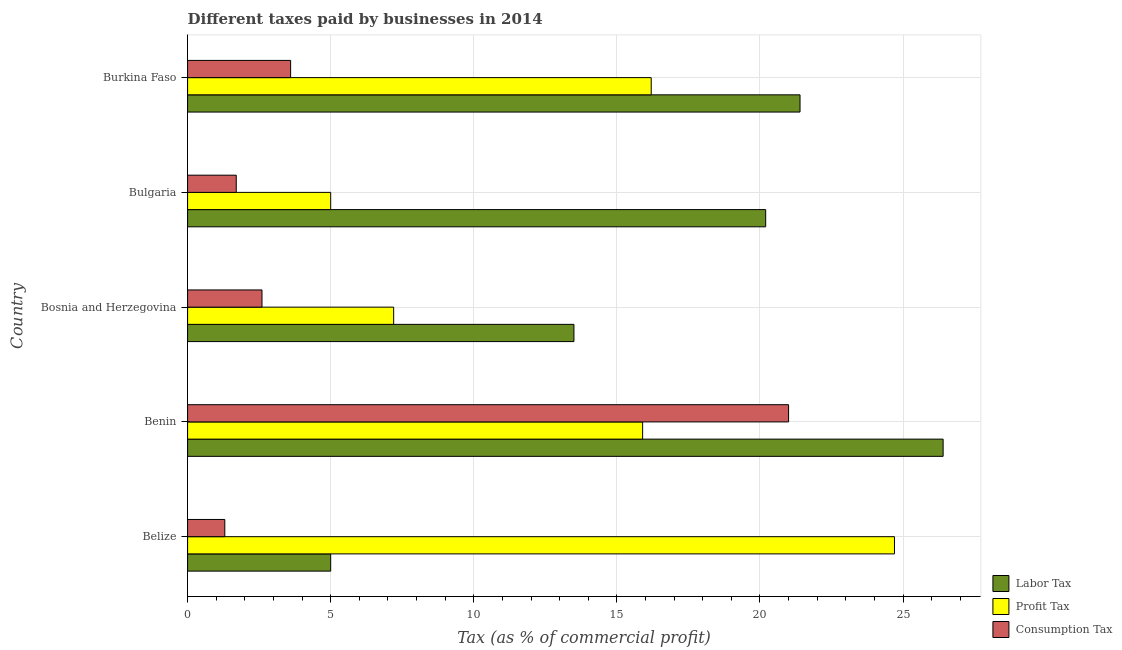How many different coloured bars are there?
Your answer should be compact. 3. How many groups of bars are there?
Provide a short and direct response. 5. How many bars are there on the 1st tick from the top?
Make the answer very short. 3. What is the label of the 2nd group of bars from the top?
Offer a terse response. Bulgaria. Across all countries, what is the maximum percentage of profit tax?
Make the answer very short. 24.7. In which country was the percentage of labor tax maximum?
Offer a very short reply. Benin. What is the total percentage of consumption tax in the graph?
Ensure brevity in your answer.  30.2. What is the difference between the percentage of consumption tax in Benin and that in Bosnia and Herzegovina?
Keep it short and to the point. 18.4. What is the difference between the percentage of consumption tax in Benin and the percentage of profit tax in Bosnia and Herzegovina?
Give a very brief answer. 13.8. In how many countries, is the percentage of profit tax greater than 13 %?
Keep it short and to the point. 3. What is the ratio of the percentage of profit tax in Belize to that in Burkina Faso?
Make the answer very short. 1.52. What is the difference between the highest and the second highest percentage of labor tax?
Provide a succinct answer. 5. What does the 3rd bar from the top in Benin represents?
Offer a very short reply. Labor Tax. What does the 1st bar from the bottom in Burkina Faso represents?
Make the answer very short. Labor Tax. Is it the case that in every country, the sum of the percentage of labor tax and percentage of profit tax is greater than the percentage of consumption tax?
Give a very brief answer. Yes. Are the values on the major ticks of X-axis written in scientific E-notation?
Make the answer very short. No. Does the graph contain any zero values?
Provide a short and direct response. No. Where does the legend appear in the graph?
Your response must be concise. Bottom right. How are the legend labels stacked?
Your answer should be very brief. Vertical. What is the title of the graph?
Make the answer very short. Different taxes paid by businesses in 2014. What is the label or title of the X-axis?
Give a very brief answer. Tax (as % of commercial profit). What is the Tax (as % of commercial profit) of Profit Tax in Belize?
Your response must be concise. 24.7. What is the Tax (as % of commercial profit) of Consumption Tax in Belize?
Offer a terse response. 1.3. What is the Tax (as % of commercial profit) in Labor Tax in Benin?
Keep it short and to the point. 26.4. What is the Tax (as % of commercial profit) in Profit Tax in Benin?
Your response must be concise. 15.9. What is the Tax (as % of commercial profit) of Labor Tax in Bosnia and Herzegovina?
Your answer should be compact. 13.5. What is the Tax (as % of commercial profit) in Profit Tax in Bosnia and Herzegovina?
Offer a very short reply. 7.2. What is the Tax (as % of commercial profit) in Labor Tax in Bulgaria?
Your answer should be compact. 20.2. What is the Tax (as % of commercial profit) in Profit Tax in Bulgaria?
Keep it short and to the point. 5. What is the Tax (as % of commercial profit) of Consumption Tax in Bulgaria?
Provide a succinct answer. 1.7. What is the Tax (as % of commercial profit) of Labor Tax in Burkina Faso?
Your answer should be compact. 21.4. What is the Tax (as % of commercial profit) of Profit Tax in Burkina Faso?
Provide a succinct answer. 16.2. What is the Tax (as % of commercial profit) of Consumption Tax in Burkina Faso?
Provide a short and direct response. 3.6. Across all countries, what is the maximum Tax (as % of commercial profit) in Labor Tax?
Offer a terse response. 26.4. Across all countries, what is the maximum Tax (as % of commercial profit) of Profit Tax?
Give a very brief answer. 24.7. Across all countries, what is the maximum Tax (as % of commercial profit) of Consumption Tax?
Offer a very short reply. 21. Across all countries, what is the minimum Tax (as % of commercial profit) in Profit Tax?
Provide a succinct answer. 5. Across all countries, what is the minimum Tax (as % of commercial profit) in Consumption Tax?
Your answer should be very brief. 1.3. What is the total Tax (as % of commercial profit) in Labor Tax in the graph?
Provide a succinct answer. 86.5. What is the total Tax (as % of commercial profit) in Consumption Tax in the graph?
Make the answer very short. 30.2. What is the difference between the Tax (as % of commercial profit) of Labor Tax in Belize and that in Benin?
Keep it short and to the point. -21.4. What is the difference between the Tax (as % of commercial profit) in Consumption Tax in Belize and that in Benin?
Provide a short and direct response. -19.7. What is the difference between the Tax (as % of commercial profit) in Profit Tax in Belize and that in Bosnia and Herzegovina?
Your answer should be compact. 17.5. What is the difference between the Tax (as % of commercial profit) of Labor Tax in Belize and that in Bulgaria?
Keep it short and to the point. -15.2. What is the difference between the Tax (as % of commercial profit) in Labor Tax in Belize and that in Burkina Faso?
Your answer should be compact. -16.4. What is the difference between the Tax (as % of commercial profit) of Profit Tax in Belize and that in Burkina Faso?
Ensure brevity in your answer.  8.5. What is the difference between the Tax (as % of commercial profit) in Labor Tax in Benin and that in Bosnia and Herzegovina?
Provide a short and direct response. 12.9. What is the difference between the Tax (as % of commercial profit) in Profit Tax in Benin and that in Bulgaria?
Ensure brevity in your answer.  10.9. What is the difference between the Tax (as % of commercial profit) in Consumption Tax in Benin and that in Bulgaria?
Your answer should be very brief. 19.3. What is the difference between the Tax (as % of commercial profit) of Labor Tax in Benin and that in Burkina Faso?
Your answer should be compact. 5. What is the difference between the Tax (as % of commercial profit) in Consumption Tax in Benin and that in Burkina Faso?
Give a very brief answer. 17.4. What is the difference between the Tax (as % of commercial profit) in Labor Tax in Bosnia and Herzegovina and that in Bulgaria?
Ensure brevity in your answer.  -6.7. What is the difference between the Tax (as % of commercial profit) in Profit Tax in Bosnia and Herzegovina and that in Bulgaria?
Your answer should be compact. 2.2. What is the difference between the Tax (as % of commercial profit) of Profit Tax in Bulgaria and that in Burkina Faso?
Provide a short and direct response. -11.2. What is the difference between the Tax (as % of commercial profit) of Consumption Tax in Bulgaria and that in Burkina Faso?
Provide a short and direct response. -1.9. What is the difference between the Tax (as % of commercial profit) of Labor Tax in Belize and the Tax (as % of commercial profit) of Profit Tax in Bosnia and Herzegovina?
Give a very brief answer. -2.2. What is the difference between the Tax (as % of commercial profit) in Profit Tax in Belize and the Tax (as % of commercial profit) in Consumption Tax in Bosnia and Herzegovina?
Your answer should be very brief. 22.1. What is the difference between the Tax (as % of commercial profit) in Labor Tax in Belize and the Tax (as % of commercial profit) in Profit Tax in Bulgaria?
Provide a short and direct response. 0. What is the difference between the Tax (as % of commercial profit) of Labor Tax in Belize and the Tax (as % of commercial profit) of Consumption Tax in Bulgaria?
Keep it short and to the point. 3.3. What is the difference between the Tax (as % of commercial profit) in Profit Tax in Belize and the Tax (as % of commercial profit) in Consumption Tax in Burkina Faso?
Offer a very short reply. 21.1. What is the difference between the Tax (as % of commercial profit) in Labor Tax in Benin and the Tax (as % of commercial profit) in Profit Tax in Bosnia and Herzegovina?
Make the answer very short. 19.2. What is the difference between the Tax (as % of commercial profit) of Labor Tax in Benin and the Tax (as % of commercial profit) of Consumption Tax in Bosnia and Herzegovina?
Ensure brevity in your answer.  23.8. What is the difference between the Tax (as % of commercial profit) in Labor Tax in Benin and the Tax (as % of commercial profit) in Profit Tax in Bulgaria?
Provide a short and direct response. 21.4. What is the difference between the Tax (as % of commercial profit) in Labor Tax in Benin and the Tax (as % of commercial profit) in Consumption Tax in Bulgaria?
Give a very brief answer. 24.7. What is the difference between the Tax (as % of commercial profit) in Profit Tax in Benin and the Tax (as % of commercial profit) in Consumption Tax in Bulgaria?
Ensure brevity in your answer.  14.2. What is the difference between the Tax (as % of commercial profit) in Labor Tax in Benin and the Tax (as % of commercial profit) in Consumption Tax in Burkina Faso?
Your answer should be very brief. 22.8. What is the difference between the Tax (as % of commercial profit) in Labor Tax in Bosnia and Herzegovina and the Tax (as % of commercial profit) in Profit Tax in Bulgaria?
Provide a short and direct response. 8.5. What is the difference between the Tax (as % of commercial profit) of Labor Tax in Bosnia and Herzegovina and the Tax (as % of commercial profit) of Consumption Tax in Bulgaria?
Provide a short and direct response. 11.8. What is the difference between the Tax (as % of commercial profit) of Profit Tax in Bosnia and Herzegovina and the Tax (as % of commercial profit) of Consumption Tax in Bulgaria?
Keep it short and to the point. 5.5. What is the difference between the Tax (as % of commercial profit) of Labor Tax in Bosnia and Herzegovina and the Tax (as % of commercial profit) of Consumption Tax in Burkina Faso?
Your answer should be compact. 9.9. What is the difference between the Tax (as % of commercial profit) in Labor Tax in Bulgaria and the Tax (as % of commercial profit) in Profit Tax in Burkina Faso?
Offer a terse response. 4. What is the difference between the Tax (as % of commercial profit) in Labor Tax in Bulgaria and the Tax (as % of commercial profit) in Consumption Tax in Burkina Faso?
Your answer should be very brief. 16.6. What is the difference between the Tax (as % of commercial profit) in Profit Tax in Bulgaria and the Tax (as % of commercial profit) in Consumption Tax in Burkina Faso?
Provide a succinct answer. 1.4. What is the average Tax (as % of commercial profit) in Profit Tax per country?
Make the answer very short. 13.8. What is the average Tax (as % of commercial profit) of Consumption Tax per country?
Your answer should be very brief. 6.04. What is the difference between the Tax (as % of commercial profit) in Labor Tax and Tax (as % of commercial profit) in Profit Tax in Belize?
Make the answer very short. -19.7. What is the difference between the Tax (as % of commercial profit) in Labor Tax and Tax (as % of commercial profit) in Consumption Tax in Belize?
Offer a terse response. 3.7. What is the difference between the Tax (as % of commercial profit) in Profit Tax and Tax (as % of commercial profit) in Consumption Tax in Belize?
Make the answer very short. 23.4. What is the difference between the Tax (as % of commercial profit) of Labor Tax and Tax (as % of commercial profit) of Profit Tax in Benin?
Your response must be concise. 10.5. What is the difference between the Tax (as % of commercial profit) in Profit Tax and Tax (as % of commercial profit) in Consumption Tax in Benin?
Your answer should be compact. -5.1. What is the difference between the Tax (as % of commercial profit) in Labor Tax and Tax (as % of commercial profit) in Profit Tax in Bosnia and Herzegovina?
Your answer should be very brief. 6.3. What is the difference between the Tax (as % of commercial profit) in Labor Tax and Tax (as % of commercial profit) in Consumption Tax in Bulgaria?
Your answer should be very brief. 18.5. What is the difference between the Tax (as % of commercial profit) of Profit Tax and Tax (as % of commercial profit) of Consumption Tax in Bulgaria?
Provide a succinct answer. 3.3. What is the difference between the Tax (as % of commercial profit) of Labor Tax and Tax (as % of commercial profit) of Profit Tax in Burkina Faso?
Provide a succinct answer. 5.2. What is the ratio of the Tax (as % of commercial profit) in Labor Tax in Belize to that in Benin?
Your answer should be compact. 0.19. What is the ratio of the Tax (as % of commercial profit) of Profit Tax in Belize to that in Benin?
Offer a very short reply. 1.55. What is the ratio of the Tax (as % of commercial profit) of Consumption Tax in Belize to that in Benin?
Make the answer very short. 0.06. What is the ratio of the Tax (as % of commercial profit) of Labor Tax in Belize to that in Bosnia and Herzegovina?
Your answer should be very brief. 0.37. What is the ratio of the Tax (as % of commercial profit) in Profit Tax in Belize to that in Bosnia and Herzegovina?
Your response must be concise. 3.43. What is the ratio of the Tax (as % of commercial profit) in Consumption Tax in Belize to that in Bosnia and Herzegovina?
Your response must be concise. 0.5. What is the ratio of the Tax (as % of commercial profit) in Labor Tax in Belize to that in Bulgaria?
Your answer should be very brief. 0.25. What is the ratio of the Tax (as % of commercial profit) in Profit Tax in Belize to that in Bulgaria?
Your answer should be compact. 4.94. What is the ratio of the Tax (as % of commercial profit) of Consumption Tax in Belize to that in Bulgaria?
Offer a very short reply. 0.76. What is the ratio of the Tax (as % of commercial profit) in Labor Tax in Belize to that in Burkina Faso?
Your answer should be very brief. 0.23. What is the ratio of the Tax (as % of commercial profit) in Profit Tax in Belize to that in Burkina Faso?
Make the answer very short. 1.52. What is the ratio of the Tax (as % of commercial profit) in Consumption Tax in Belize to that in Burkina Faso?
Offer a very short reply. 0.36. What is the ratio of the Tax (as % of commercial profit) in Labor Tax in Benin to that in Bosnia and Herzegovina?
Your answer should be compact. 1.96. What is the ratio of the Tax (as % of commercial profit) in Profit Tax in Benin to that in Bosnia and Herzegovina?
Offer a terse response. 2.21. What is the ratio of the Tax (as % of commercial profit) in Consumption Tax in Benin to that in Bosnia and Herzegovina?
Your response must be concise. 8.08. What is the ratio of the Tax (as % of commercial profit) of Labor Tax in Benin to that in Bulgaria?
Provide a succinct answer. 1.31. What is the ratio of the Tax (as % of commercial profit) of Profit Tax in Benin to that in Bulgaria?
Ensure brevity in your answer.  3.18. What is the ratio of the Tax (as % of commercial profit) of Consumption Tax in Benin to that in Bulgaria?
Your answer should be very brief. 12.35. What is the ratio of the Tax (as % of commercial profit) in Labor Tax in Benin to that in Burkina Faso?
Ensure brevity in your answer.  1.23. What is the ratio of the Tax (as % of commercial profit) in Profit Tax in Benin to that in Burkina Faso?
Your response must be concise. 0.98. What is the ratio of the Tax (as % of commercial profit) of Consumption Tax in Benin to that in Burkina Faso?
Provide a succinct answer. 5.83. What is the ratio of the Tax (as % of commercial profit) in Labor Tax in Bosnia and Herzegovina to that in Bulgaria?
Provide a succinct answer. 0.67. What is the ratio of the Tax (as % of commercial profit) of Profit Tax in Bosnia and Herzegovina to that in Bulgaria?
Your answer should be very brief. 1.44. What is the ratio of the Tax (as % of commercial profit) of Consumption Tax in Bosnia and Herzegovina to that in Bulgaria?
Make the answer very short. 1.53. What is the ratio of the Tax (as % of commercial profit) in Labor Tax in Bosnia and Herzegovina to that in Burkina Faso?
Make the answer very short. 0.63. What is the ratio of the Tax (as % of commercial profit) of Profit Tax in Bosnia and Herzegovina to that in Burkina Faso?
Offer a very short reply. 0.44. What is the ratio of the Tax (as % of commercial profit) of Consumption Tax in Bosnia and Herzegovina to that in Burkina Faso?
Offer a very short reply. 0.72. What is the ratio of the Tax (as % of commercial profit) in Labor Tax in Bulgaria to that in Burkina Faso?
Provide a short and direct response. 0.94. What is the ratio of the Tax (as % of commercial profit) in Profit Tax in Bulgaria to that in Burkina Faso?
Your response must be concise. 0.31. What is the ratio of the Tax (as % of commercial profit) in Consumption Tax in Bulgaria to that in Burkina Faso?
Your response must be concise. 0.47. What is the difference between the highest and the second highest Tax (as % of commercial profit) of Profit Tax?
Make the answer very short. 8.5. What is the difference between the highest and the second highest Tax (as % of commercial profit) in Consumption Tax?
Your answer should be compact. 17.4. What is the difference between the highest and the lowest Tax (as % of commercial profit) in Labor Tax?
Give a very brief answer. 21.4. What is the difference between the highest and the lowest Tax (as % of commercial profit) of Consumption Tax?
Your answer should be compact. 19.7. 